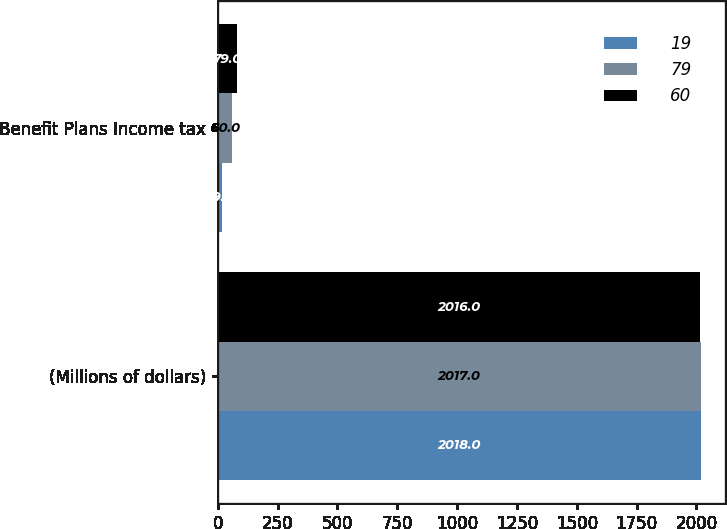<chart> <loc_0><loc_0><loc_500><loc_500><stacked_bar_chart><ecel><fcel>(Millions of dollars)<fcel>Benefit Plans Income tax<nl><fcel>19<fcel>2018<fcel>19<nl><fcel>79<fcel>2017<fcel>60<nl><fcel>60<fcel>2016<fcel>79<nl></chart> 